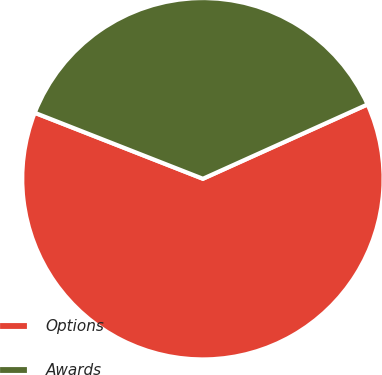Convert chart. <chart><loc_0><loc_0><loc_500><loc_500><pie_chart><fcel>Options<fcel>Awards<nl><fcel>62.7%<fcel>37.3%<nl></chart> 